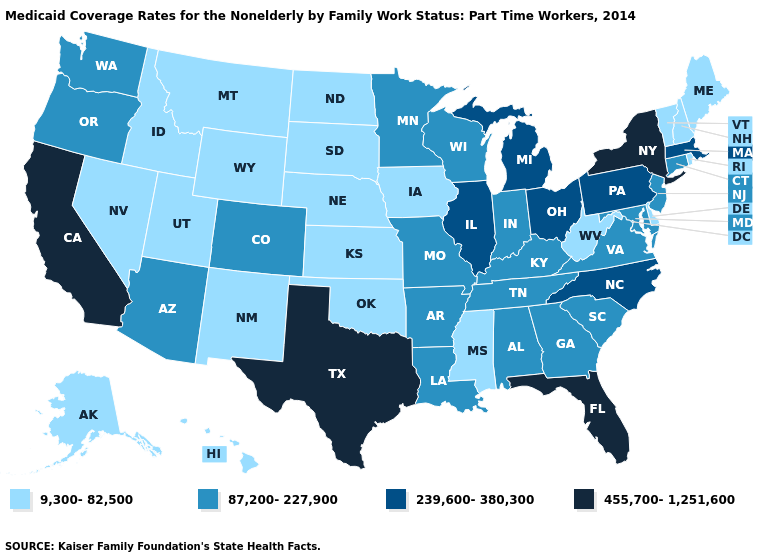What is the highest value in states that border Connecticut?
Concise answer only. 455,700-1,251,600. Does Mississippi have a lower value than Illinois?
Concise answer only. Yes. Name the states that have a value in the range 9,300-82,500?
Answer briefly. Alaska, Delaware, Hawaii, Idaho, Iowa, Kansas, Maine, Mississippi, Montana, Nebraska, Nevada, New Hampshire, New Mexico, North Dakota, Oklahoma, Rhode Island, South Dakota, Utah, Vermont, West Virginia, Wyoming. Name the states that have a value in the range 9,300-82,500?
Give a very brief answer. Alaska, Delaware, Hawaii, Idaho, Iowa, Kansas, Maine, Mississippi, Montana, Nebraska, Nevada, New Hampshire, New Mexico, North Dakota, Oklahoma, Rhode Island, South Dakota, Utah, Vermont, West Virginia, Wyoming. Among the states that border Iowa , which have the lowest value?
Keep it brief. Nebraska, South Dakota. Among the states that border Ohio , which have the lowest value?
Be succinct. West Virginia. What is the lowest value in the MidWest?
Short answer required. 9,300-82,500. What is the lowest value in the MidWest?
Answer briefly. 9,300-82,500. Name the states that have a value in the range 87,200-227,900?
Write a very short answer. Alabama, Arizona, Arkansas, Colorado, Connecticut, Georgia, Indiana, Kentucky, Louisiana, Maryland, Minnesota, Missouri, New Jersey, Oregon, South Carolina, Tennessee, Virginia, Washington, Wisconsin. Does the first symbol in the legend represent the smallest category?
Write a very short answer. Yes. What is the value of Nevada?
Concise answer only. 9,300-82,500. Is the legend a continuous bar?
Short answer required. No. Which states have the lowest value in the South?
Concise answer only. Delaware, Mississippi, Oklahoma, West Virginia. Among the states that border Louisiana , does Mississippi have the highest value?
Quick response, please. No. Which states have the lowest value in the MidWest?
Concise answer only. Iowa, Kansas, Nebraska, North Dakota, South Dakota. 